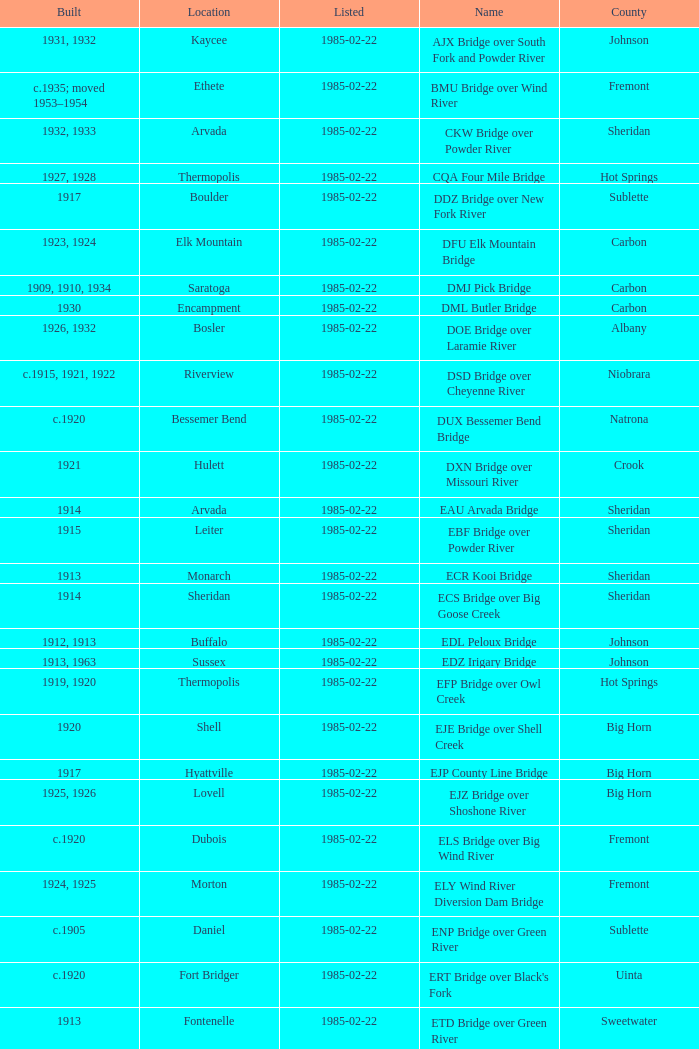What bridge in Sheridan county was built in 1915? EBF Bridge over Powder River. 